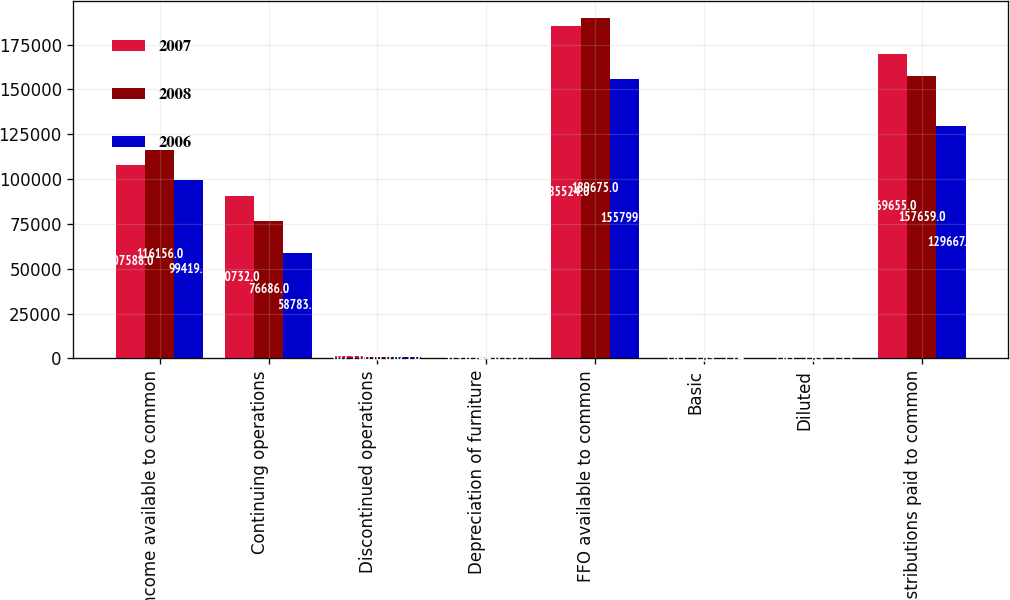<chart> <loc_0><loc_0><loc_500><loc_500><stacked_bar_chart><ecel><fcel>Net income available to common<fcel>Continuing operations<fcel>Discontinued operations<fcel>Depreciation of furniture<fcel>FFO available to common<fcel>Basic<fcel>Diluted<fcel>Distributions paid to common<nl><fcel>2007<fcel>107588<fcel>90732<fcel>1073<fcel>319<fcel>185524<fcel>1.83<fcel>1.83<fcel>169655<nl><fcel>2008<fcel>116156<fcel>76686<fcel>636<fcel>244<fcel>189675<fcel>1.89<fcel>1.89<fcel>157659<nl><fcel>2006<fcel>99419<fcel>58783<fcel>825<fcel>192<fcel>155799<fcel>1.74<fcel>1.73<fcel>129667<nl></chart> 